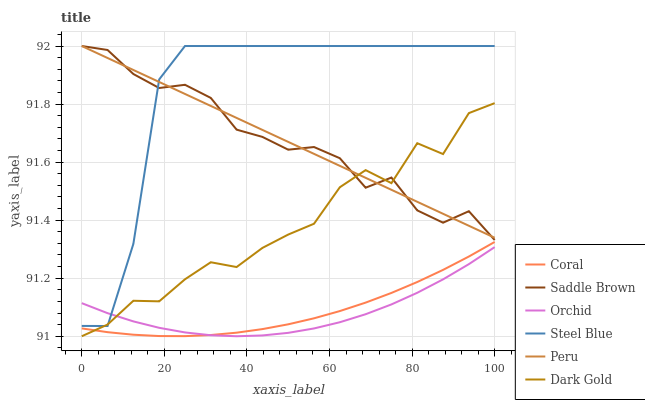Does Orchid have the minimum area under the curve?
Answer yes or no. Yes. Does Steel Blue have the maximum area under the curve?
Answer yes or no. Yes. Does Coral have the minimum area under the curve?
Answer yes or no. No. Does Coral have the maximum area under the curve?
Answer yes or no. No. Is Peru the smoothest?
Answer yes or no. Yes. Is Dark Gold the roughest?
Answer yes or no. Yes. Is Coral the smoothest?
Answer yes or no. No. Is Coral the roughest?
Answer yes or no. No. Does Dark Gold have the lowest value?
Answer yes or no. Yes. Does Coral have the lowest value?
Answer yes or no. No. Does Saddle Brown have the highest value?
Answer yes or no. Yes. Does Coral have the highest value?
Answer yes or no. No. Is Orchid less than Saddle Brown?
Answer yes or no. Yes. Is Steel Blue greater than Coral?
Answer yes or no. Yes. Does Orchid intersect Steel Blue?
Answer yes or no. Yes. Is Orchid less than Steel Blue?
Answer yes or no. No. Is Orchid greater than Steel Blue?
Answer yes or no. No. Does Orchid intersect Saddle Brown?
Answer yes or no. No. 